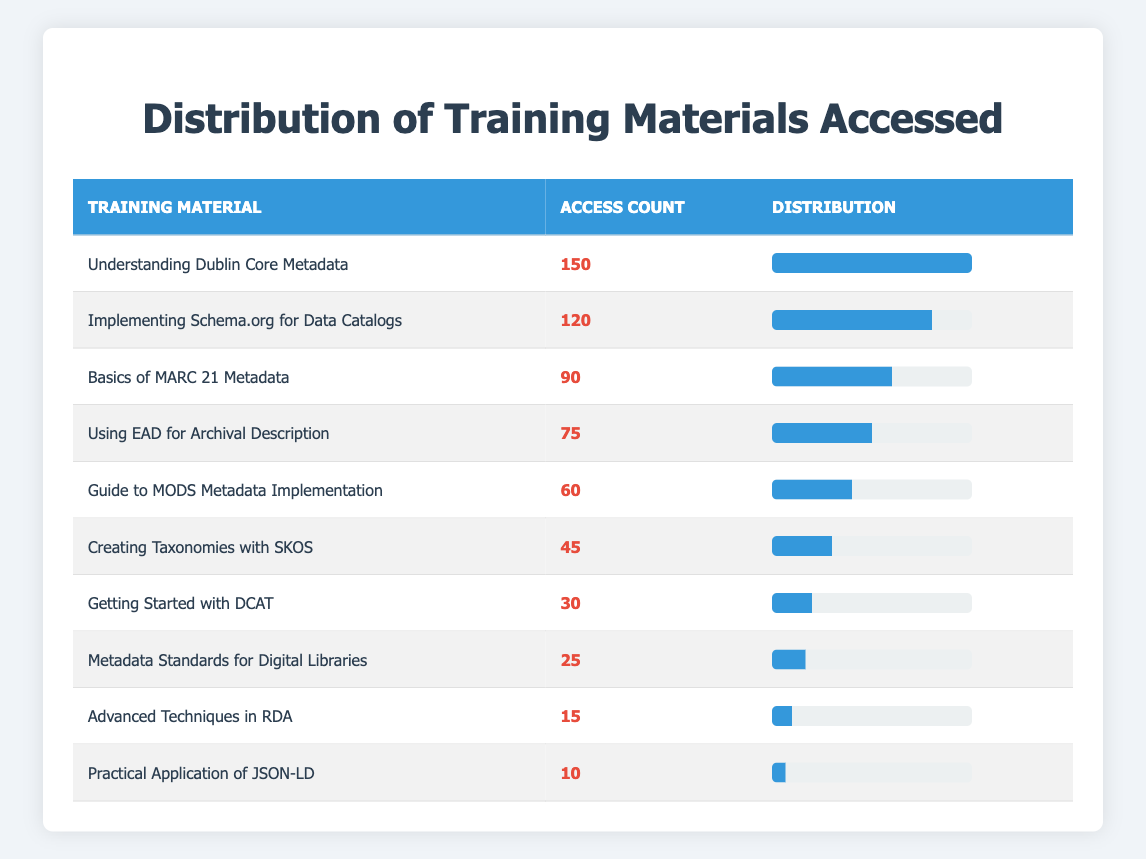What training material had the highest access count? The access count for each training material is listed in the table. By scanning the access count values, "Understanding Dublin Core Metadata" shows the highest access count of 150.
Answer: Understanding Dublin Core Metadata How many users accessed "Creating Taxonomies with SKOS"? The access count for "Creating Taxonomies with SKOS" is stated in the table as 45.
Answer: 45 What is the total access count of all training materials listed in the table? To find the total access count, we sum the access counts of all materials: 150 + 120 + 90 + 75 + 60 + 45 + 30 + 25 + 15 + 10 = 600.
Answer: 600 Is the access count for "Metadata Standards for Digital Libraries" greater than that for "Getting Started with DCAT"? The access count for "Metadata Standards for Digital Libraries" is 25, while for "Getting Started with DCAT," it is 30. Thus, 25 is not greater than 30, making this statement false.
Answer: No What percentage of the total access count does "Practical Application of JSON-LD" represent? The access count for "Practical Application of JSON-LD" is 10. The total access count is 600. So, we calculate (10 / 600) * 100 = 1.67%.
Answer: 1.67% 